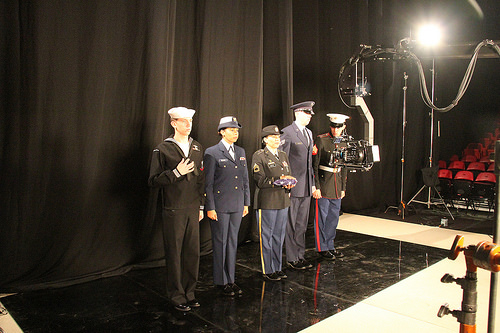<image>
Is the hat on the woman? No. The hat is not positioned on the woman. They may be near each other, but the hat is not supported by or resting on top of the woman. Where is the woman in relation to the man? Is it to the right of the man? Yes. From this viewpoint, the woman is positioned to the right side relative to the man. Is there a people in front of the camera? Yes. The people is positioned in front of the camera, appearing closer to the camera viewpoint. 